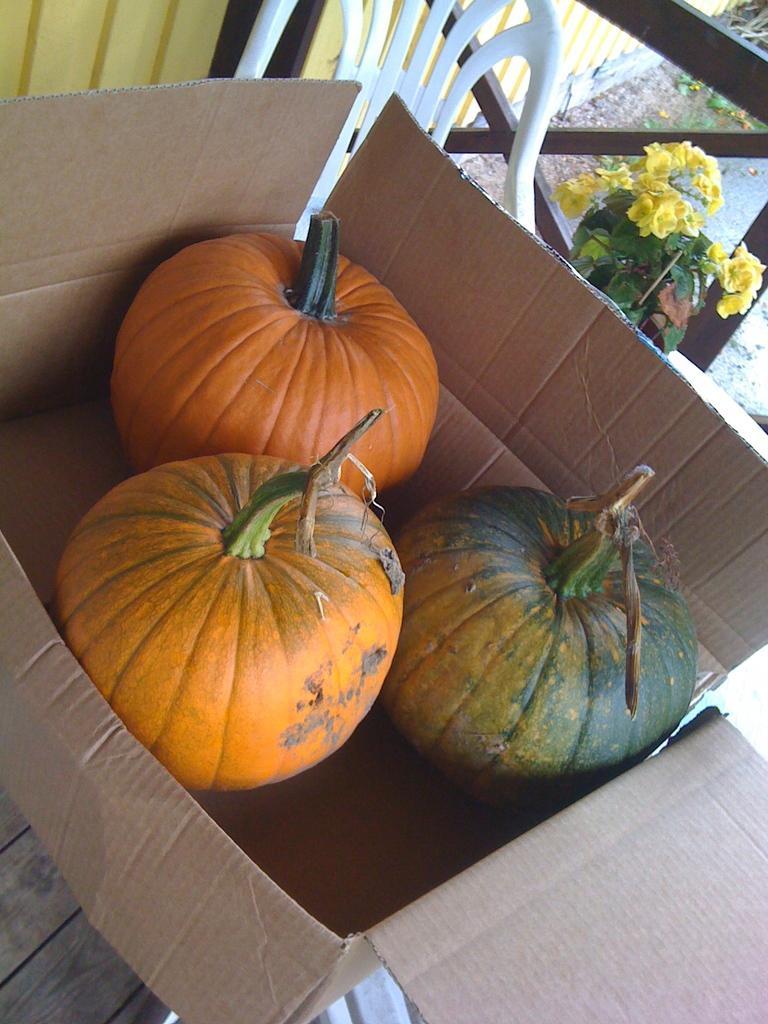How would you summarize this image in a sentence or two? In this image we can see a box with pumpkins in it on the table. In the background of the image there is a chair. There is a flower plant. There is wall. There is a wooden grill. 